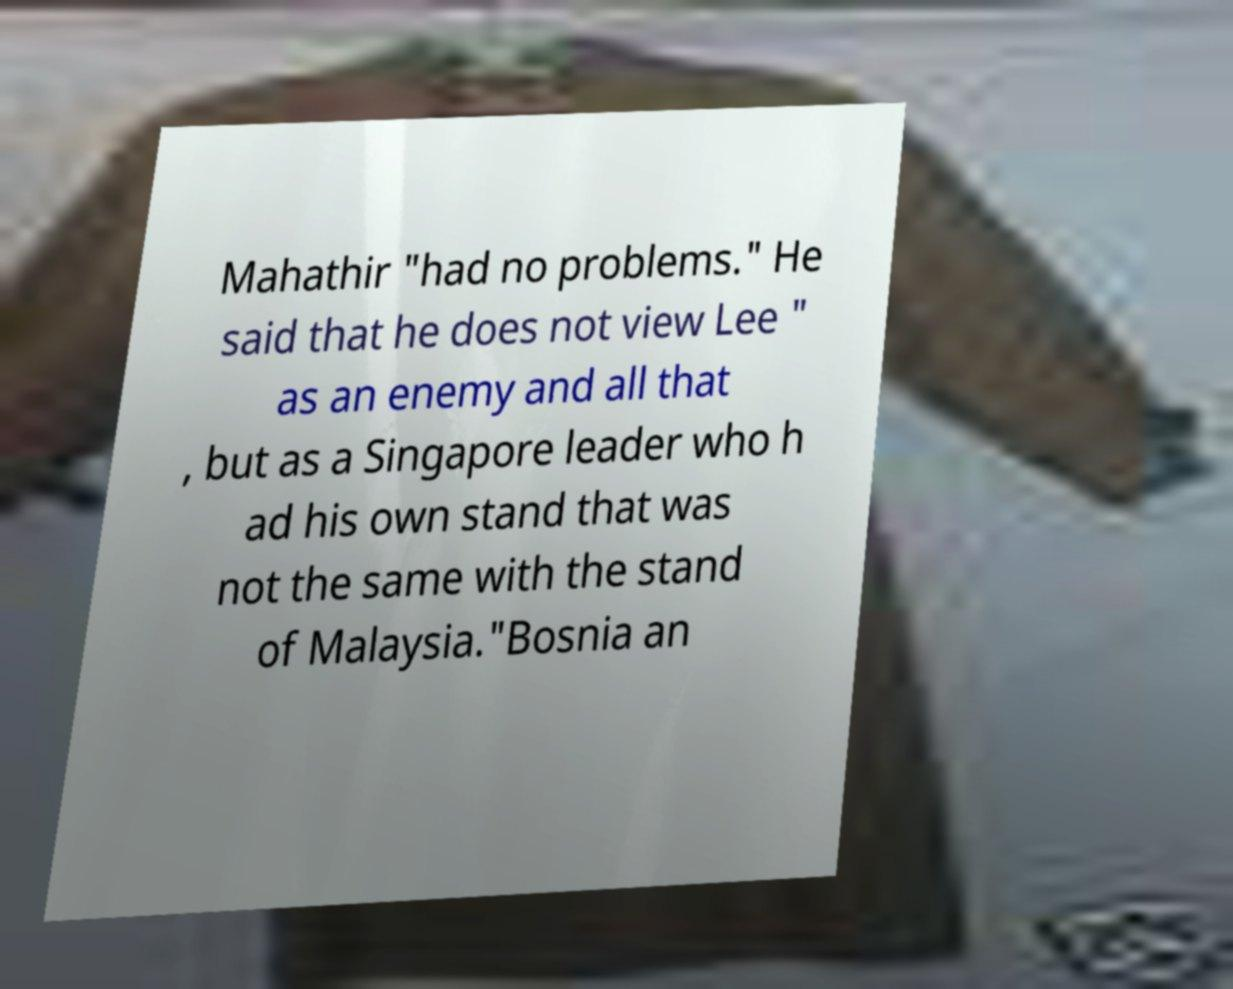What messages or text are displayed in this image? I need them in a readable, typed format. Mahathir "had no problems." He said that he does not view Lee " as an enemy and all that , but as a Singapore leader who h ad his own stand that was not the same with the stand of Malaysia."Bosnia an 